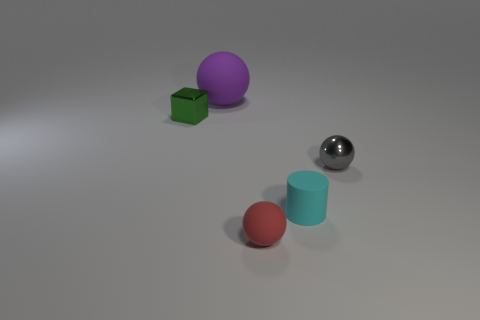There is a matte sphere that is behind the small metallic object that is on the right side of the small metal object that is behind the small metallic sphere; what size is it?
Offer a very short reply. Large. Is the number of small green blocks greater than the number of big brown matte spheres?
Offer a terse response. Yes. There is a sphere behind the metallic cube; does it have the same color as the small metal thing to the right of the small green object?
Your answer should be very brief. No. Does the cyan object that is in front of the large matte ball have the same material as the tiny ball that is to the left of the small gray shiny ball?
Give a very brief answer. Yes. How many other purple matte things have the same size as the purple rubber thing?
Offer a very short reply. 0. Is the number of red matte balls less than the number of big green cylinders?
Offer a very short reply. No. The small metallic thing that is behind the ball to the right of the cylinder is what shape?
Provide a succinct answer. Cube. The red thing that is the same size as the green metallic block is what shape?
Your response must be concise. Sphere. Are there any tiny gray metallic objects that have the same shape as the small red object?
Offer a terse response. Yes. What is the material of the small cyan object?
Your response must be concise. Rubber. 